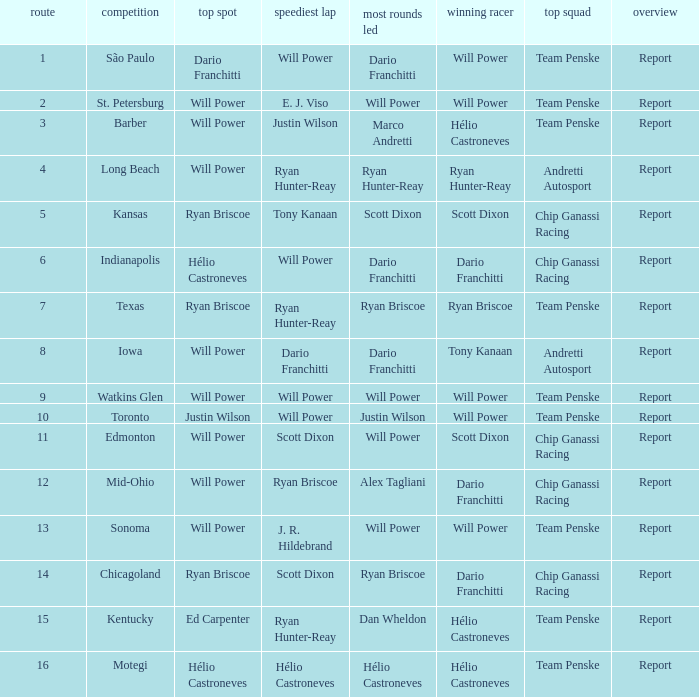Who was on the pole at Chicagoland? Ryan Briscoe. 